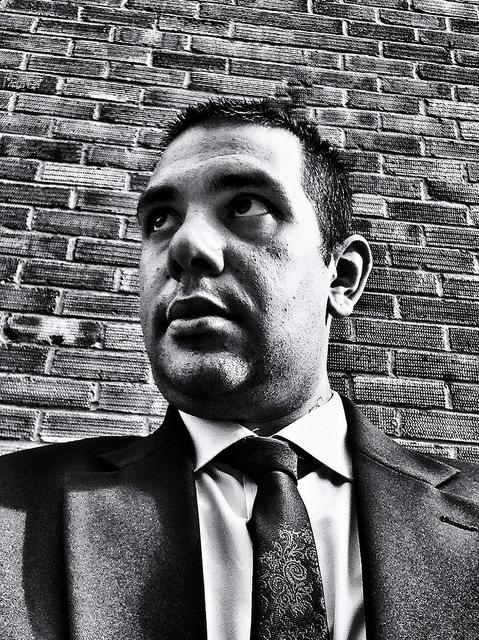What is featured in the background of this image?
Short answer required. Bricks. What is this man wearing?
Answer briefly. Suit. Is the man looking directly into the camera?
Be succinct. No. 